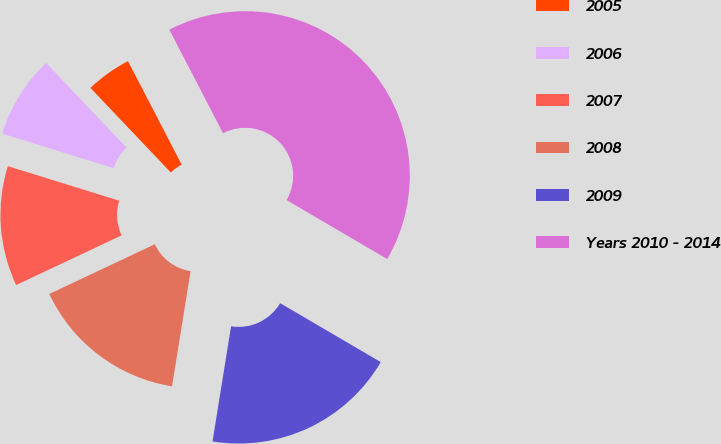<chart> <loc_0><loc_0><loc_500><loc_500><pie_chart><fcel>2005<fcel>2006<fcel>2007<fcel>2008<fcel>2009<fcel>Years 2010 - 2014<nl><fcel>4.47%<fcel>8.13%<fcel>11.79%<fcel>15.45%<fcel>19.11%<fcel>41.05%<nl></chart> 